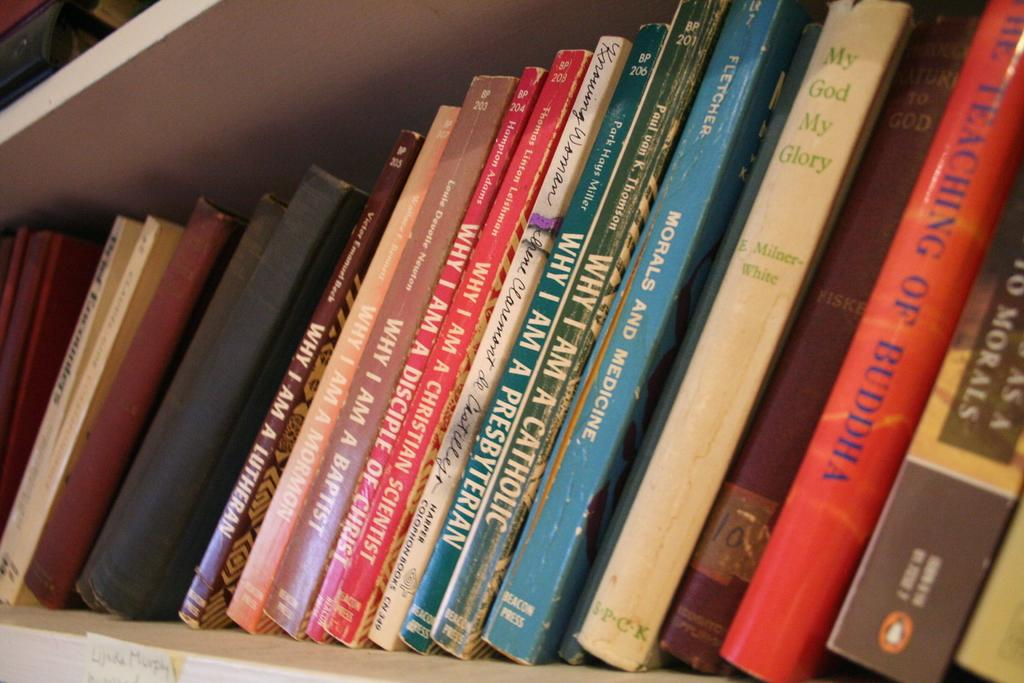<image>
Offer a succinct explanation of the picture presented. The book in red on the right is called The Teaching of Buddha 